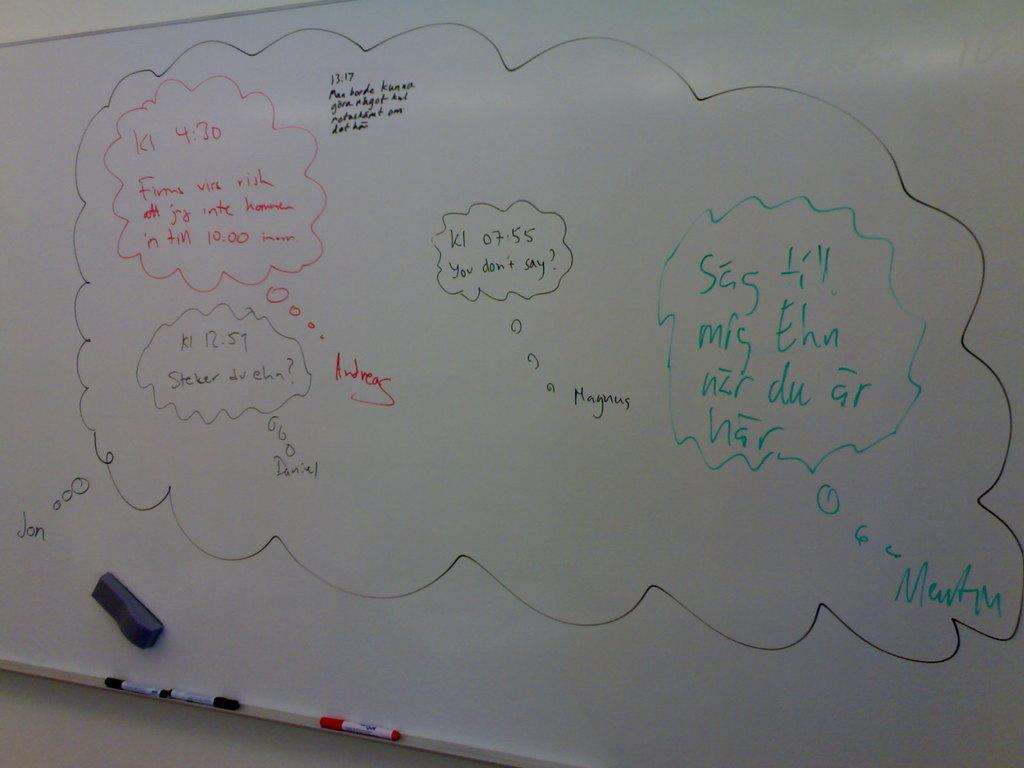Whose thought bubble included the words, you don't say?
Provide a succinct answer. Magnus. Who said what was in green?
Provide a short and direct response. Martin. 